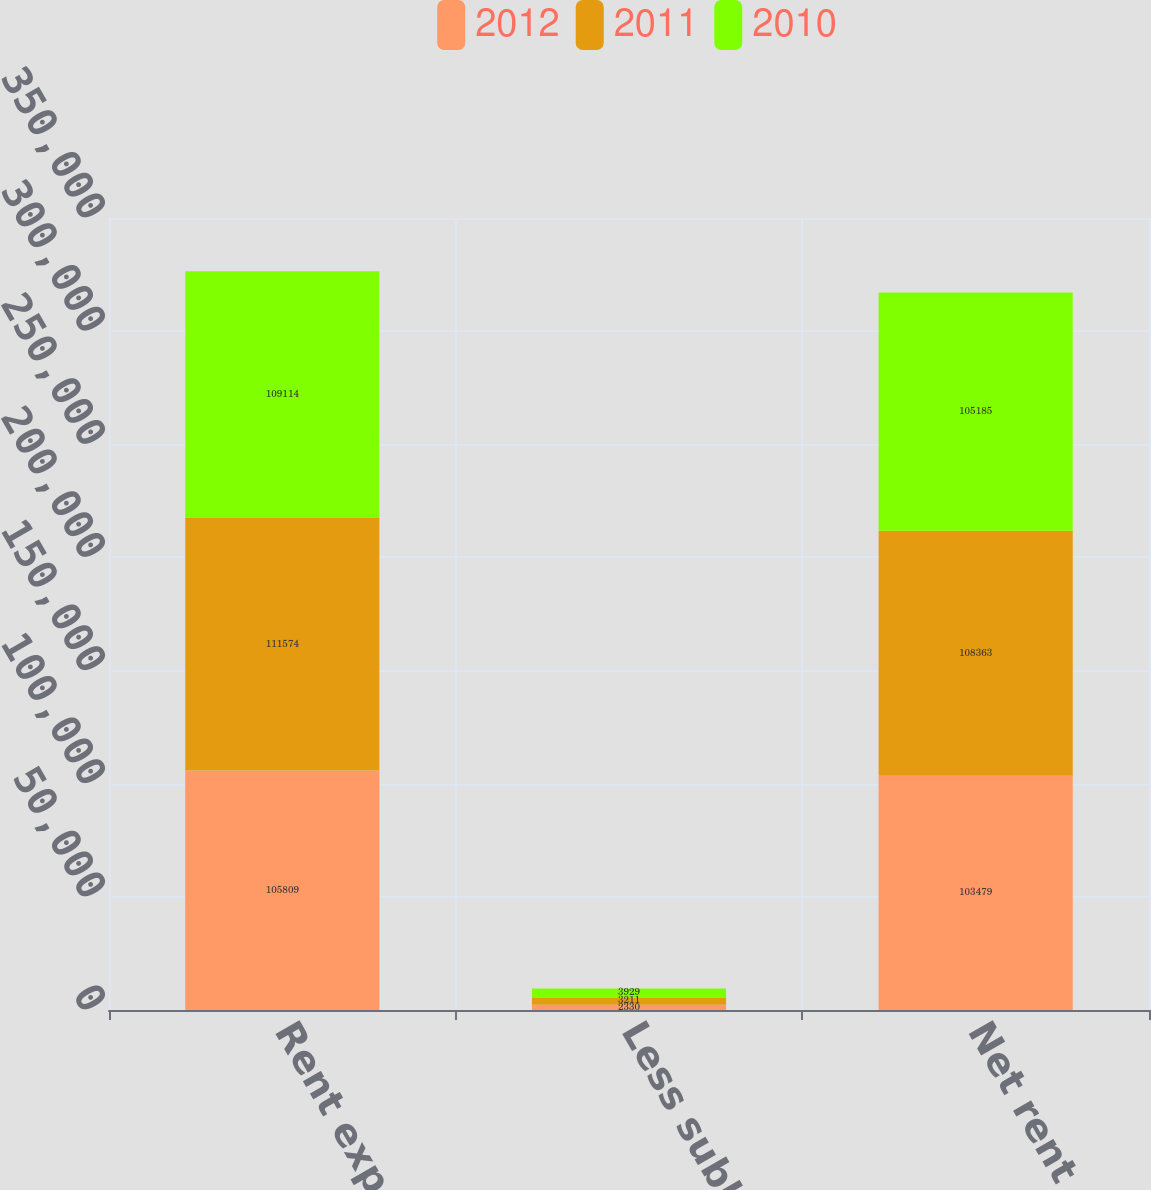Convert chart. <chart><loc_0><loc_0><loc_500><loc_500><stacked_bar_chart><ecel><fcel>Rent expense<fcel>Less sublease income<fcel>Net rent expense<nl><fcel>2012<fcel>105809<fcel>2330<fcel>103479<nl><fcel>2011<fcel>111574<fcel>3211<fcel>108363<nl><fcel>2010<fcel>109114<fcel>3929<fcel>105185<nl></chart> 